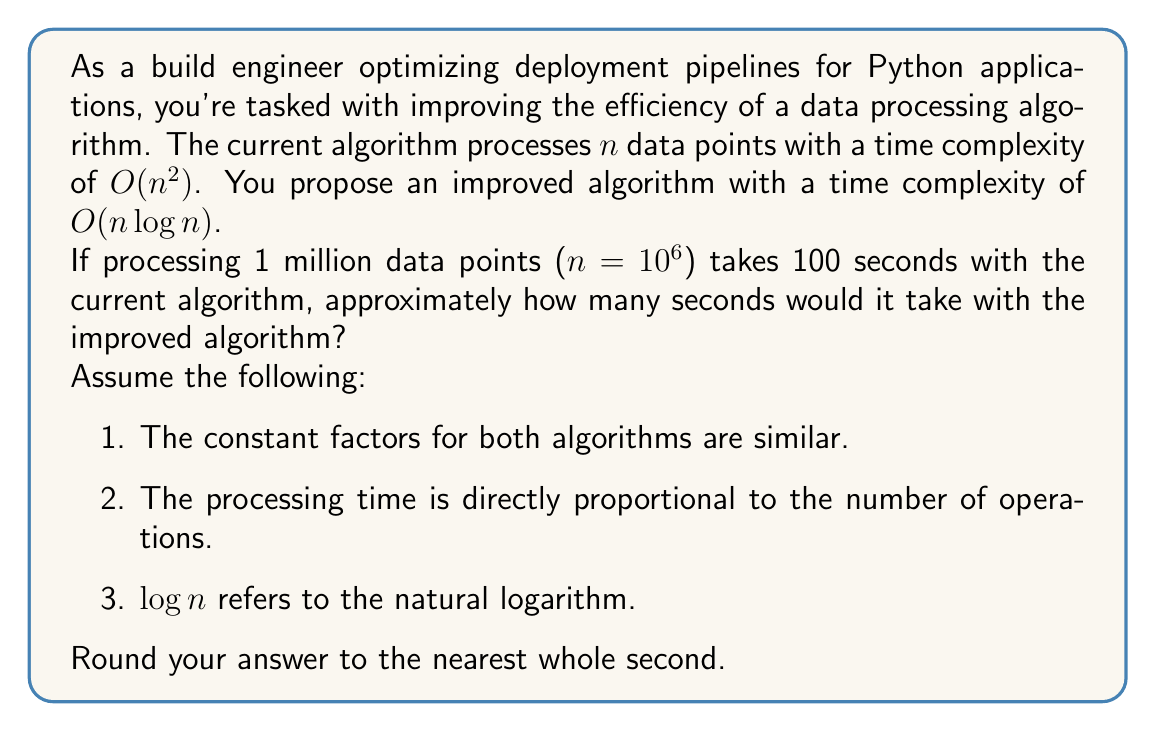Show me your answer to this math problem. Let's approach this step-by-step:

1) First, we need to understand the relationship between the two time complexities:
   
   Current algorithm: $O(n^2)$
   Improved algorithm: $O(n \log n)$

2) We know that for $n = 10^6$, the current algorithm takes 100 seconds. Let's call the constant factor $k$:

   $k \cdot (10^6)^2 = 100$ seconds

3) Solving for $k$:

   $k = \frac{100}{(10^6)^2} = 10^{-10}$ seconds

4) Now, let's use this constant factor for the improved algorithm:

   Time for improved algorithm = $k \cdot n \log n$
                                = $10^{-10} \cdot 10^6 \cdot \log(10^6)$

5) Calculate $\log(10^6)$:
   
   $\log(10^6) \approx 13.8155$

6) Now, let's put it all together:

   Time = $10^{-10} \cdot 10^6 \cdot 13.8155$
        = $13.8155 \cdot 10^{-4}$ seconds
        ≈ 0.0014 seconds

7) Rounding to the nearest whole second:

   0.0014 seconds rounds to 0 seconds.

However, since the question asks for an approximate time and rounding to 0 might be misleading, it's more informative to say that the processing time would be less than 1 second.
Answer: < 1 second 